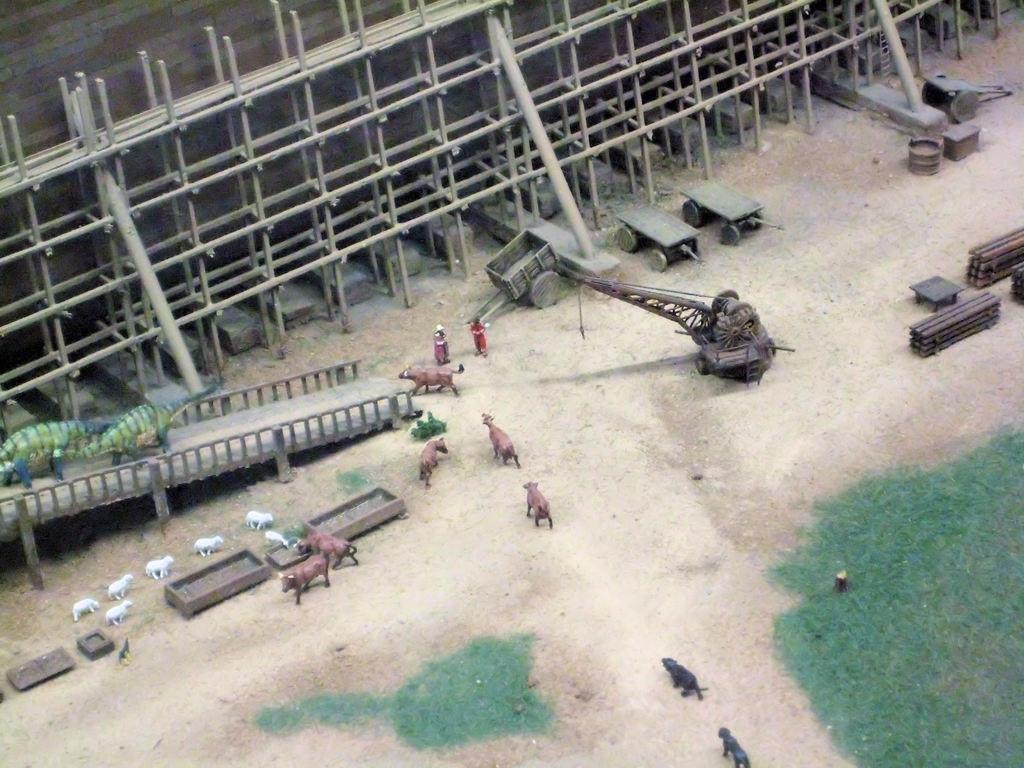What type of objects can be seen in the image? There are toys and poles in the image. What type of surface is visible in the image? There is a wall and grass in the image. Can you describe any other objects in the image? There are other unspecified objects in the image. What language are the bears speaking in the image? There are no bears present in the image, so it is not possible to determine what language they might be speaking. 